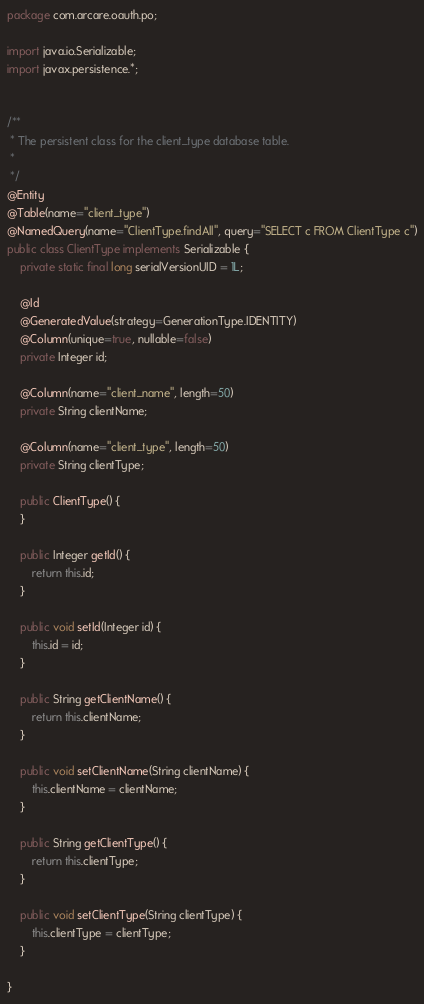Convert code to text. <code><loc_0><loc_0><loc_500><loc_500><_Java_>package com.arcare.oauth.po;

import java.io.Serializable;
import javax.persistence.*;


/**
 * The persistent class for the client_type database table.
 * 
 */
@Entity
@Table(name="client_type")
@NamedQuery(name="ClientType.findAll", query="SELECT c FROM ClientType c")
public class ClientType implements Serializable {
	private static final long serialVersionUID = 1L;

	@Id
	@GeneratedValue(strategy=GenerationType.IDENTITY)
	@Column(unique=true, nullable=false)
	private Integer id;

	@Column(name="client_name", length=50)
	private String clientName;

	@Column(name="client_type", length=50)
	private String clientType;

	public ClientType() {
	}

	public Integer getId() {
		return this.id;
	}

	public void setId(Integer id) {
		this.id = id;
	}

	public String getClientName() {
		return this.clientName;
	}

	public void setClientName(String clientName) {
		this.clientName = clientName;
	}

	public String getClientType() {
		return this.clientType;
	}

	public void setClientType(String clientType) {
		this.clientType = clientType;
	}

}</code> 